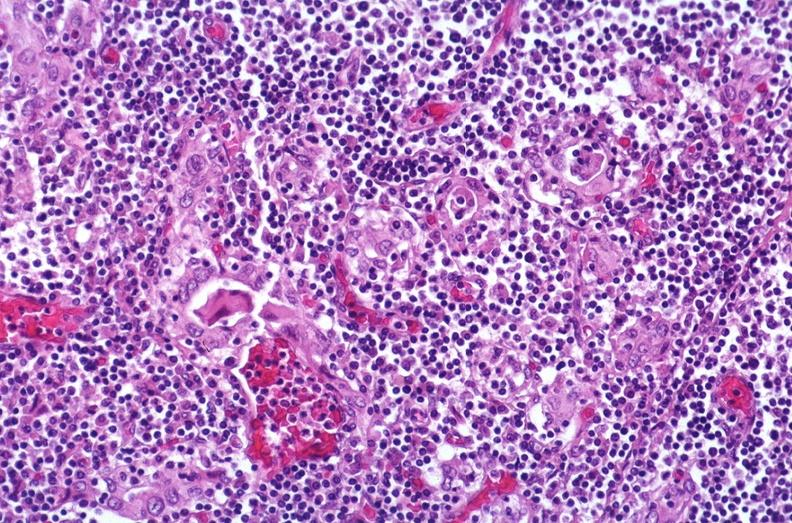where is this part in the figure?
Answer the question using a single word or phrase. Endocrine system 